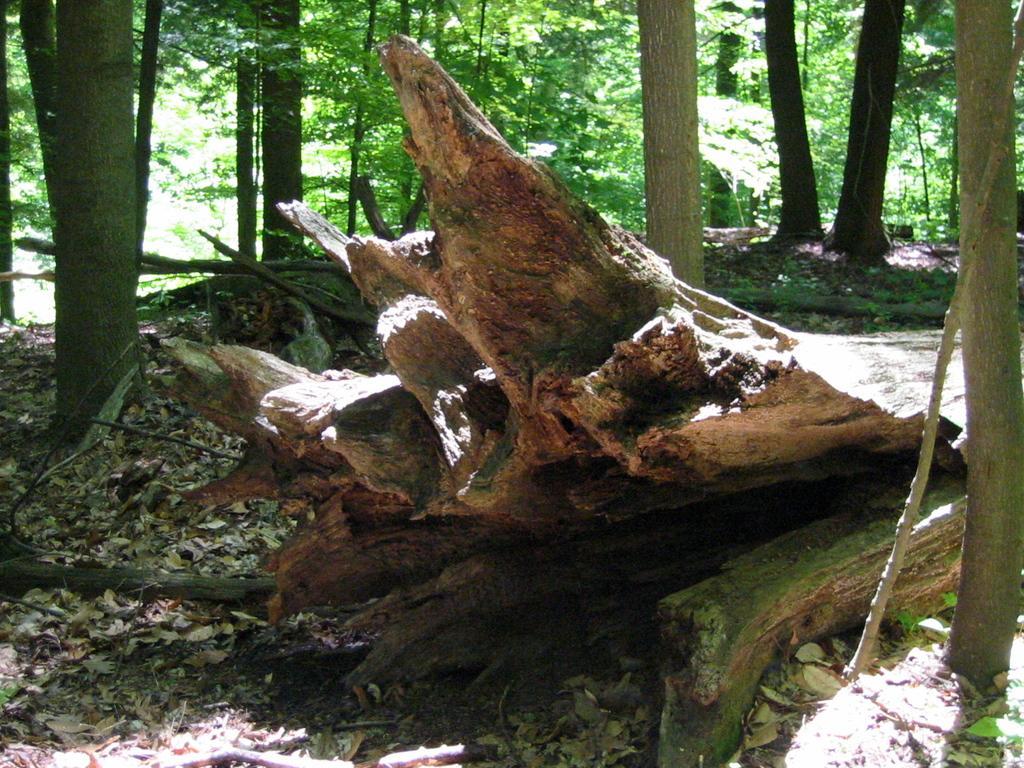Please provide a concise description of this image. In this picture we can see wooden logs, dried leaves on the ground and in the background we can see trees. 